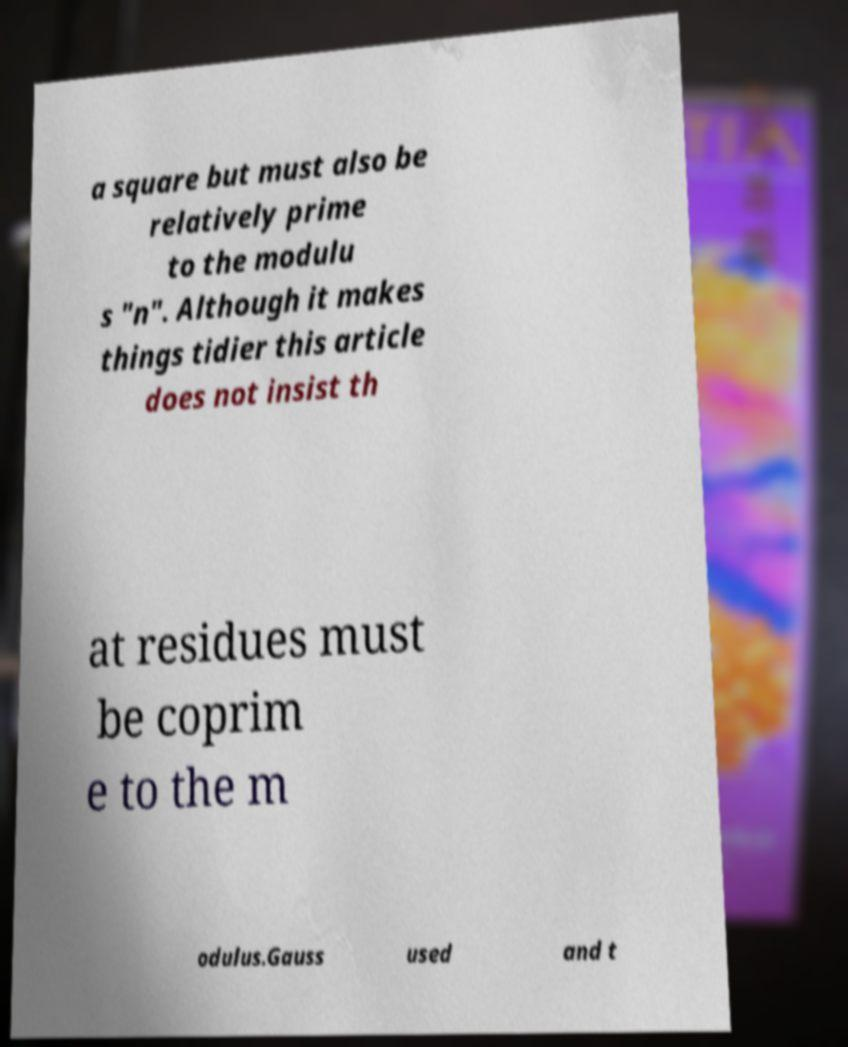Can you read and provide the text displayed in the image?This photo seems to have some interesting text. Can you extract and type it out for me? a square but must also be relatively prime to the modulu s "n". Although it makes things tidier this article does not insist th at residues must be coprim e to the m odulus.Gauss used and t 